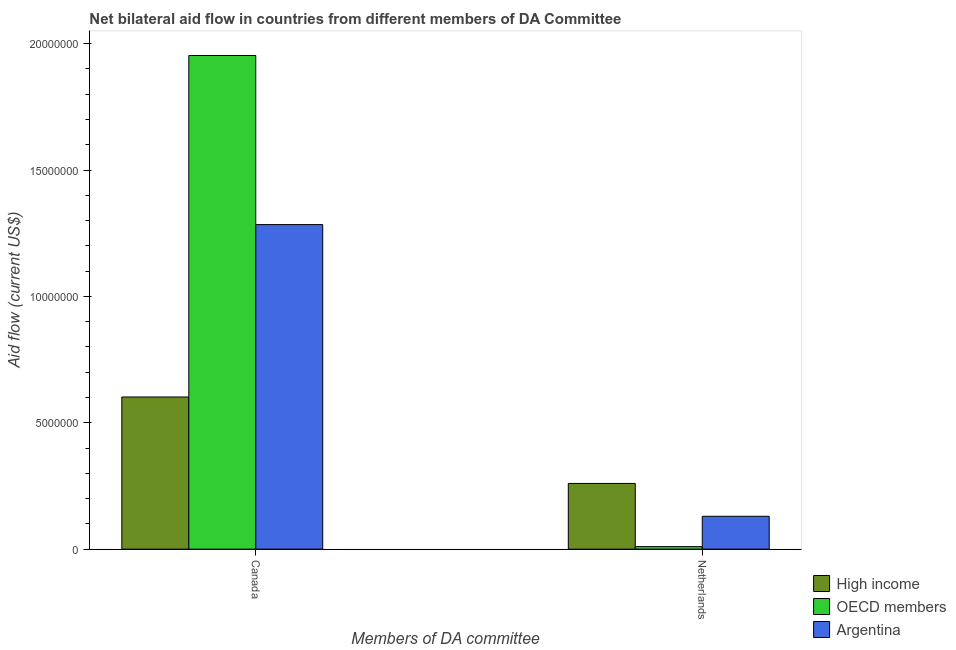How many groups of bars are there?
Your answer should be very brief. 2. Are the number of bars per tick equal to the number of legend labels?
Make the answer very short. Yes. How many bars are there on the 1st tick from the left?
Provide a succinct answer. 3. What is the amount of aid given by netherlands in High income?
Provide a succinct answer. 2.60e+06. Across all countries, what is the maximum amount of aid given by netherlands?
Offer a terse response. 2.60e+06. Across all countries, what is the minimum amount of aid given by netherlands?
Your answer should be very brief. 1.00e+05. In which country was the amount of aid given by canada maximum?
Your answer should be compact. OECD members. In which country was the amount of aid given by netherlands minimum?
Your answer should be compact. OECD members. What is the total amount of aid given by canada in the graph?
Your answer should be compact. 3.84e+07. What is the difference between the amount of aid given by canada in Argentina and that in High income?
Provide a succinct answer. 6.82e+06. What is the difference between the amount of aid given by canada in Argentina and the amount of aid given by netherlands in OECD members?
Your answer should be compact. 1.27e+07. What is the average amount of aid given by netherlands per country?
Keep it short and to the point. 1.33e+06. What is the difference between the amount of aid given by canada and amount of aid given by netherlands in High income?
Ensure brevity in your answer.  3.42e+06. What is the ratio of the amount of aid given by netherlands in High income to that in OECD members?
Your response must be concise. 26. Is the amount of aid given by canada in Argentina less than that in OECD members?
Make the answer very short. Yes. How many bars are there?
Provide a succinct answer. 6. Are all the bars in the graph horizontal?
Provide a succinct answer. No. What is the difference between two consecutive major ticks on the Y-axis?
Keep it short and to the point. 5.00e+06. Where does the legend appear in the graph?
Ensure brevity in your answer.  Bottom right. How are the legend labels stacked?
Make the answer very short. Vertical. What is the title of the graph?
Keep it short and to the point. Net bilateral aid flow in countries from different members of DA Committee. Does "Lower middle income" appear as one of the legend labels in the graph?
Keep it short and to the point. No. What is the label or title of the X-axis?
Give a very brief answer. Members of DA committee. What is the label or title of the Y-axis?
Make the answer very short. Aid flow (current US$). What is the Aid flow (current US$) of High income in Canada?
Give a very brief answer. 6.02e+06. What is the Aid flow (current US$) of OECD members in Canada?
Your answer should be compact. 1.95e+07. What is the Aid flow (current US$) of Argentina in Canada?
Your answer should be very brief. 1.28e+07. What is the Aid flow (current US$) of High income in Netherlands?
Offer a very short reply. 2.60e+06. What is the Aid flow (current US$) in Argentina in Netherlands?
Your answer should be compact. 1.30e+06. Across all Members of DA committee, what is the maximum Aid flow (current US$) in High income?
Your response must be concise. 6.02e+06. Across all Members of DA committee, what is the maximum Aid flow (current US$) of OECD members?
Keep it short and to the point. 1.95e+07. Across all Members of DA committee, what is the maximum Aid flow (current US$) in Argentina?
Ensure brevity in your answer.  1.28e+07. Across all Members of DA committee, what is the minimum Aid flow (current US$) of High income?
Your response must be concise. 2.60e+06. Across all Members of DA committee, what is the minimum Aid flow (current US$) in OECD members?
Keep it short and to the point. 1.00e+05. Across all Members of DA committee, what is the minimum Aid flow (current US$) of Argentina?
Offer a terse response. 1.30e+06. What is the total Aid flow (current US$) in High income in the graph?
Offer a terse response. 8.62e+06. What is the total Aid flow (current US$) of OECD members in the graph?
Offer a very short reply. 1.96e+07. What is the total Aid flow (current US$) of Argentina in the graph?
Provide a succinct answer. 1.41e+07. What is the difference between the Aid flow (current US$) in High income in Canada and that in Netherlands?
Make the answer very short. 3.42e+06. What is the difference between the Aid flow (current US$) in OECD members in Canada and that in Netherlands?
Ensure brevity in your answer.  1.94e+07. What is the difference between the Aid flow (current US$) in Argentina in Canada and that in Netherlands?
Keep it short and to the point. 1.15e+07. What is the difference between the Aid flow (current US$) in High income in Canada and the Aid flow (current US$) in OECD members in Netherlands?
Your answer should be compact. 5.92e+06. What is the difference between the Aid flow (current US$) in High income in Canada and the Aid flow (current US$) in Argentina in Netherlands?
Offer a very short reply. 4.72e+06. What is the difference between the Aid flow (current US$) of OECD members in Canada and the Aid flow (current US$) of Argentina in Netherlands?
Your response must be concise. 1.82e+07. What is the average Aid flow (current US$) of High income per Members of DA committee?
Provide a short and direct response. 4.31e+06. What is the average Aid flow (current US$) in OECD members per Members of DA committee?
Make the answer very short. 9.82e+06. What is the average Aid flow (current US$) in Argentina per Members of DA committee?
Offer a terse response. 7.07e+06. What is the difference between the Aid flow (current US$) in High income and Aid flow (current US$) in OECD members in Canada?
Keep it short and to the point. -1.35e+07. What is the difference between the Aid flow (current US$) in High income and Aid flow (current US$) in Argentina in Canada?
Offer a very short reply. -6.82e+06. What is the difference between the Aid flow (current US$) in OECD members and Aid flow (current US$) in Argentina in Canada?
Keep it short and to the point. 6.69e+06. What is the difference between the Aid flow (current US$) in High income and Aid flow (current US$) in OECD members in Netherlands?
Make the answer very short. 2.50e+06. What is the difference between the Aid flow (current US$) of High income and Aid flow (current US$) of Argentina in Netherlands?
Give a very brief answer. 1.30e+06. What is the difference between the Aid flow (current US$) of OECD members and Aid flow (current US$) of Argentina in Netherlands?
Your answer should be compact. -1.20e+06. What is the ratio of the Aid flow (current US$) of High income in Canada to that in Netherlands?
Your answer should be very brief. 2.32. What is the ratio of the Aid flow (current US$) in OECD members in Canada to that in Netherlands?
Give a very brief answer. 195.3. What is the ratio of the Aid flow (current US$) in Argentina in Canada to that in Netherlands?
Offer a terse response. 9.88. What is the difference between the highest and the second highest Aid flow (current US$) in High income?
Your response must be concise. 3.42e+06. What is the difference between the highest and the second highest Aid flow (current US$) of OECD members?
Your response must be concise. 1.94e+07. What is the difference between the highest and the second highest Aid flow (current US$) in Argentina?
Make the answer very short. 1.15e+07. What is the difference between the highest and the lowest Aid flow (current US$) in High income?
Offer a terse response. 3.42e+06. What is the difference between the highest and the lowest Aid flow (current US$) in OECD members?
Your response must be concise. 1.94e+07. What is the difference between the highest and the lowest Aid flow (current US$) in Argentina?
Provide a short and direct response. 1.15e+07. 